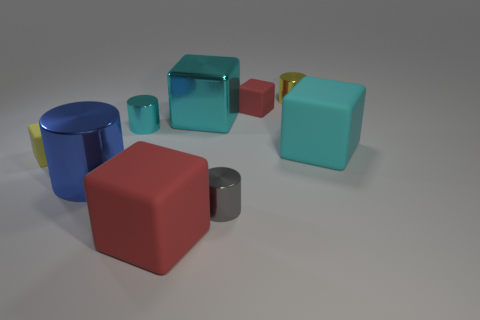Does the blue thing have the same shape as the large shiny object that is behind the big cyan rubber thing?
Offer a very short reply. No. There is a large cube that is left of the big cyan rubber cube and behind the blue thing; what is its material?
Your response must be concise. Metal. There is a shiny cylinder that is the same size as the cyan matte object; what is its color?
Offer a terse response. Blue. Is the material of the small cyan cylinder the same as the yellow object that is behind the large cyan matte cube?
Your answer should be very brief. Yes. What number of other objects are there of the same size as the cyan metal block?
Provide a succinct answer. 3. There is a red thing that is on the left side of the small cube right of the yellow block; is there a blue object to the left of it?
Your response must be concise. Yes. How big is the gray thing?
Offer a terse response. Small. How big is the cyan block that is behind the cyan rubber cube?
Keep it short and to the point. Large. There is a cyan block that is to the left of the gray shiny object; is it the same size as the large blue cylinder?
Provide a short and direct response. Yes. Are there any other things that have the same color as the shiny cube?
Your answer should be very brief. Yes. 